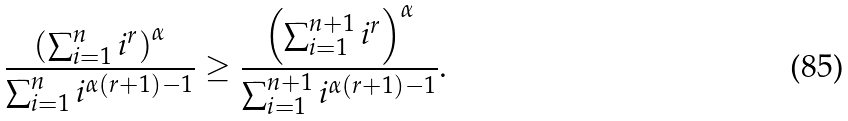Convert formula to latex. <formula><loc_0><loc_0><loc_500><loc_500>\frac { \left ( \sum ^ { n } _ { i = 1 } i ^ { r } \right ) ^ { \alpha } } { \sum ^ { n } _ { i = 1 } i ^ { \alpha ( r + 1 ) - 1 } } \geq \frac { \left ( \sum ^ { n + 1 } _ { i = 1 } i ^ { r } \right ) ^ { \alpha } } { \sum ^ { n + 1 } _ { i = 1 } i ^ { \alpha ( r + 1 ) - 1 } } .</formula> 